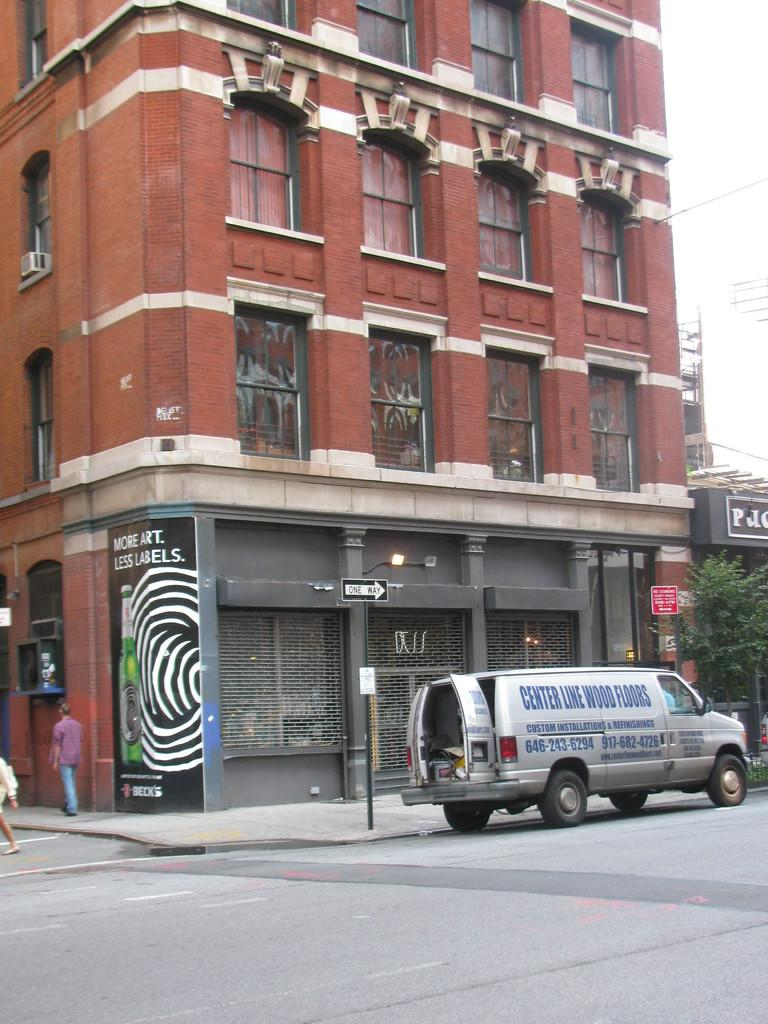Provide a one-sentence caption for the provided image. The back doors are open on a van advertising Center Line Wood Floors which is parked at the curb by a building. 